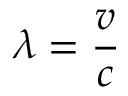<formula> <loc_0><loc_0><loc_500><loc_500>\lambda = { \frac { v } { c } }</formula> 